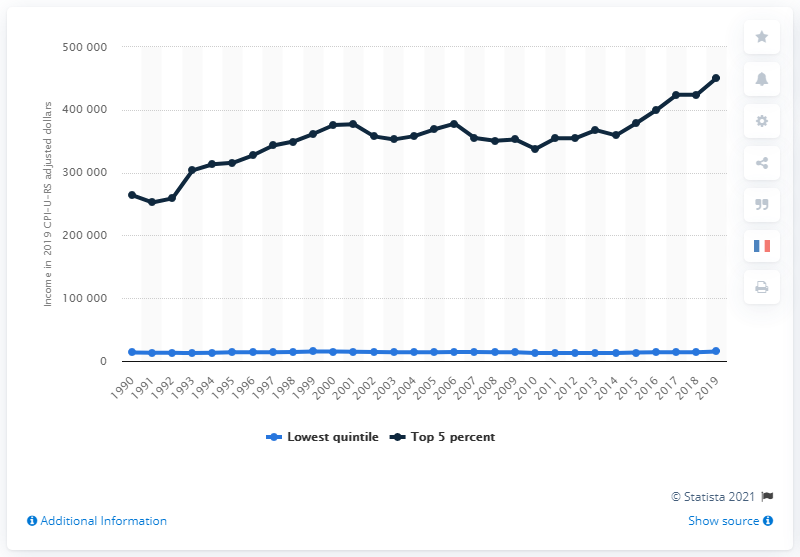Outline some significant characteristics in this image. In 2019, the U.S. dollar was used to determine the median household income for low-paid workers in the lowest quintile. 